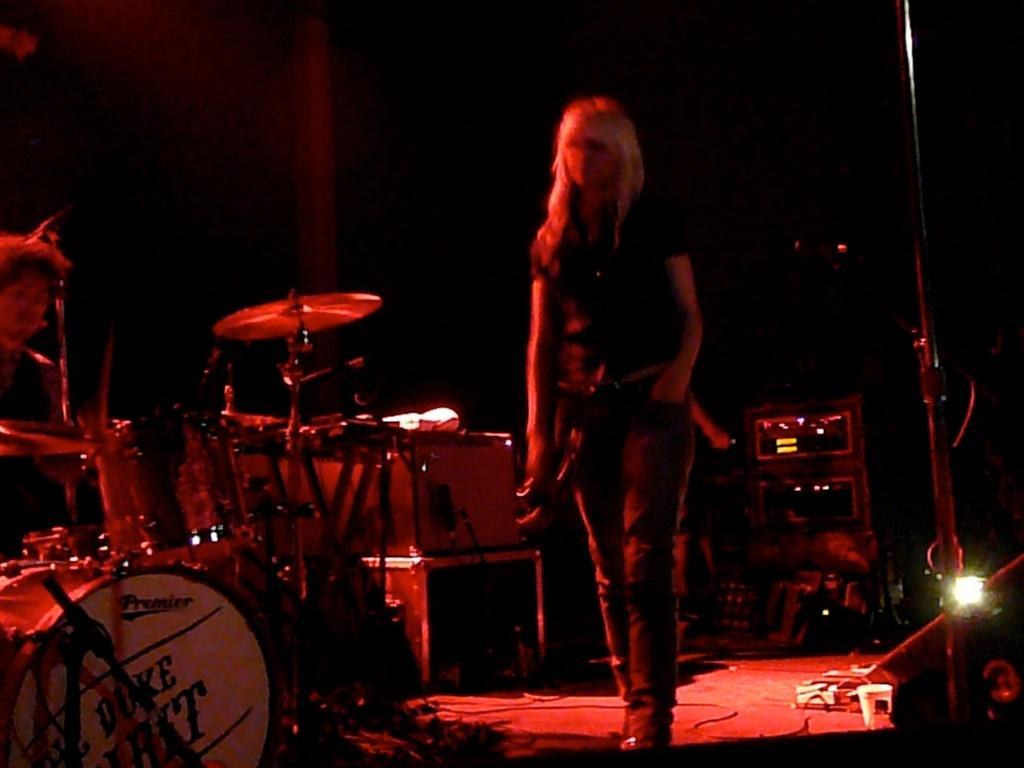How would you summarize this image in a sentence or two? There is a woman walking on a stage. On which, there are musical instruments, speakers and a light arranged. And the background is dark in color. 